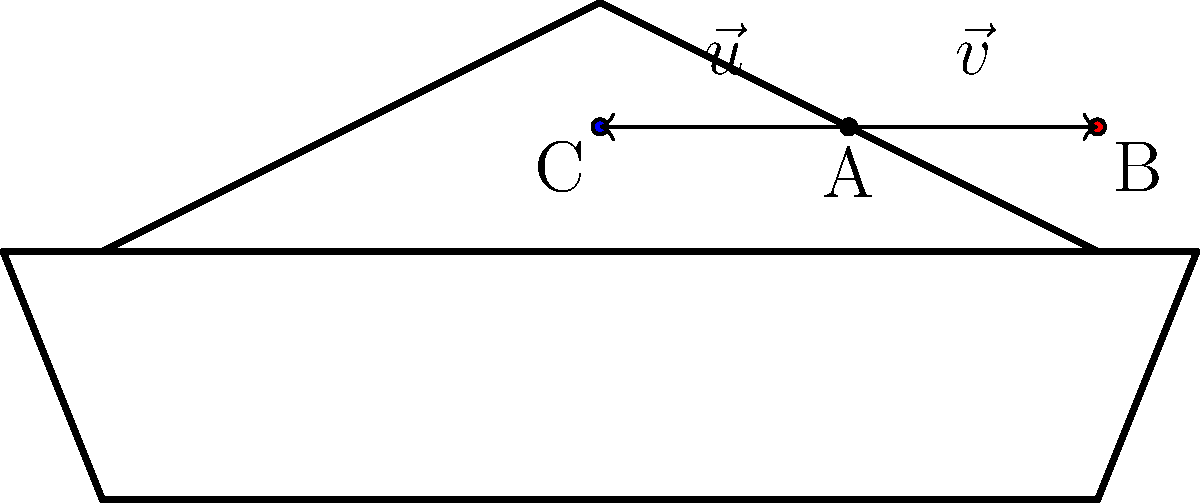As a motorsports agent, you're tasked with optimizing sponsor logo placement on a race car. Given that $\vec{u} = \langle -0.4, 0 \rangle$ and $\vec{v} = \langle 0.4, 0 \rangle$ represent vectors from point A to C and A to B respectively, calculate the angle between these vectors to determine the optimal spread of logos. What is the angle in degrees? To find the angle between two vectors, we can use the dot product formula:

$$\cos \theta = \frac{\vec{u} \cdot \vec{v}}{|\vec{u}||\vec{v}|}$$

Step 1: Calculate the dot product of $\vec{u}$ and $\vec{v}$:
$\vec{u} \cdot \vec{v} = (-0.4)(0.4) + (0)(0) = -0.16$

Step 2: Calculate the magnitudes of $\vec{u}$ and $\vec{v}$:
$|\vec{u}| = \sqrt{(-0.4)^2 + 0^2} = 0.4$
$|\vec{v}| = \sqrt{(0.4)^2 + 0^2} = 0.4$

Step 3: Substitute into the formula:
$$\cos \theta = \frac{-0.16}{(0.4)(0.4)} = -1$$

Step 4: Solve for $\theta$:
$$\theta = \arccos(-1) = \pi \text{ radians}$$

Step 5: Convert to degrees:
$$\theta = \pi \text{ radians} \times \frac{180^\circ}{\pi} = 180^\circ$$

Therefore, the angle between the vectors, representing the optimal spread of logos, is 180°.
Answer: 180° 